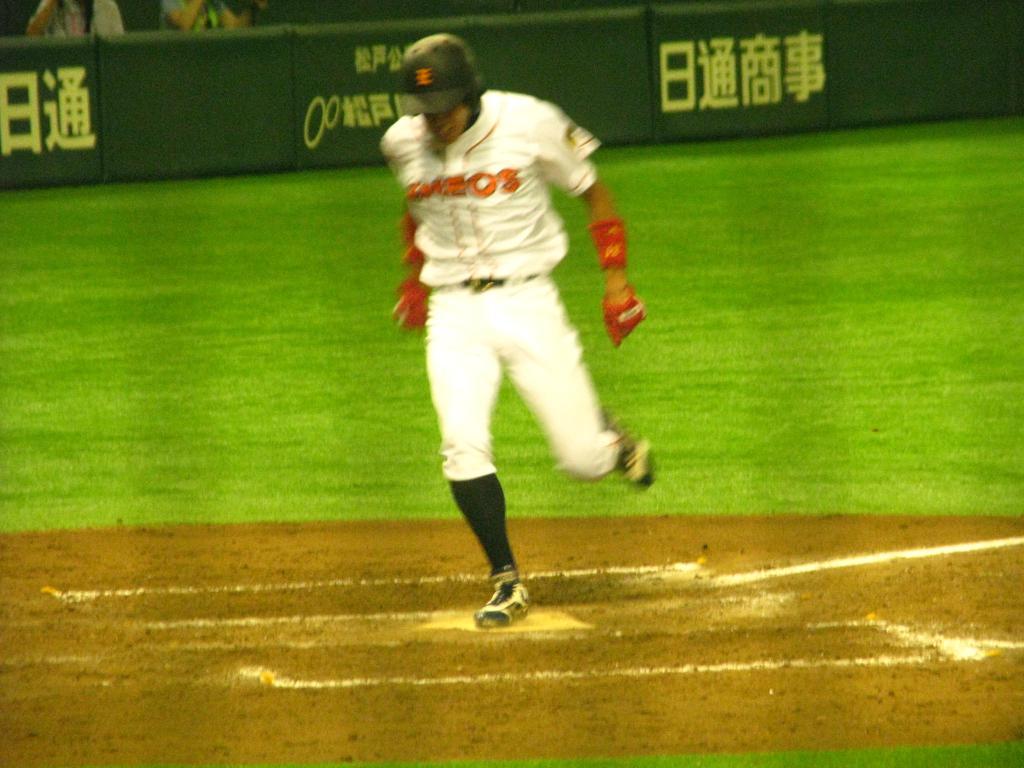What's the big red letter 2nd to last on his jersey?
Offer a terse response. O. 